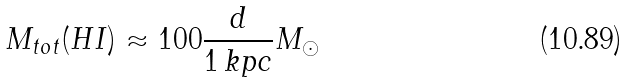<formula> <loc_0><loc_0><loc_500><loc_500>M _ { t o t } ( H I ) \approx 1 0 0 \frac { d } { 1 \, k p c } M _ { \odot }</formula> 